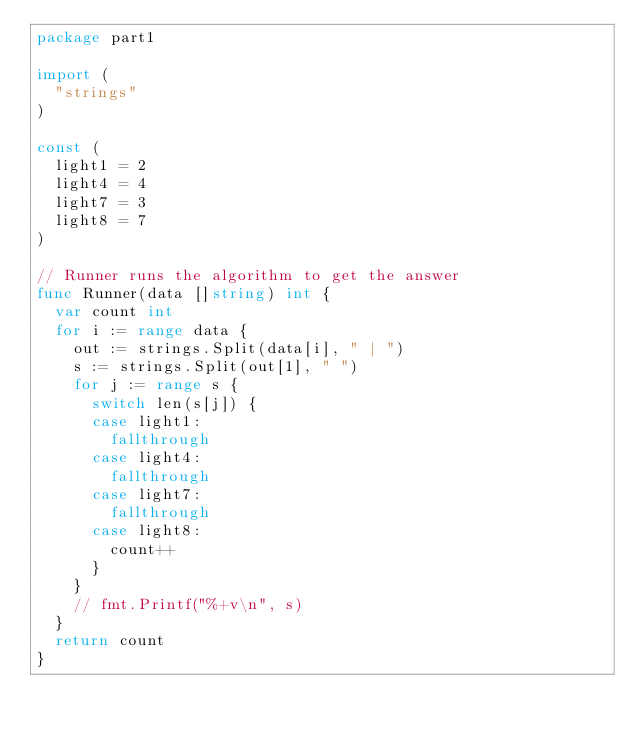Convert code to text. <code><loc_0><loc_0><loc_500><loc_500><_Go_>package part1

import (
	"strings"
)

const (
	light1 = 2
	light4 = 4
	light7 = 3
	light8 = 7
)

// Runner runs the algorithm to get the answer
func Runner(data []string) int {
	var count int
	for i := range data {
		out := strings.Split(data[i], " | ")
		s := strings.Split(out[1], " ")
		for j := range s {
			switch len(s[j]) {
			case light1:
				fallthrough
			case light4:
				fallthrough
			case light7:
				fallthrough
			case light8:
				count++
			}
		}
		// fmt.Printf("%+v\n", s)
	}
	return count
}
</code> 